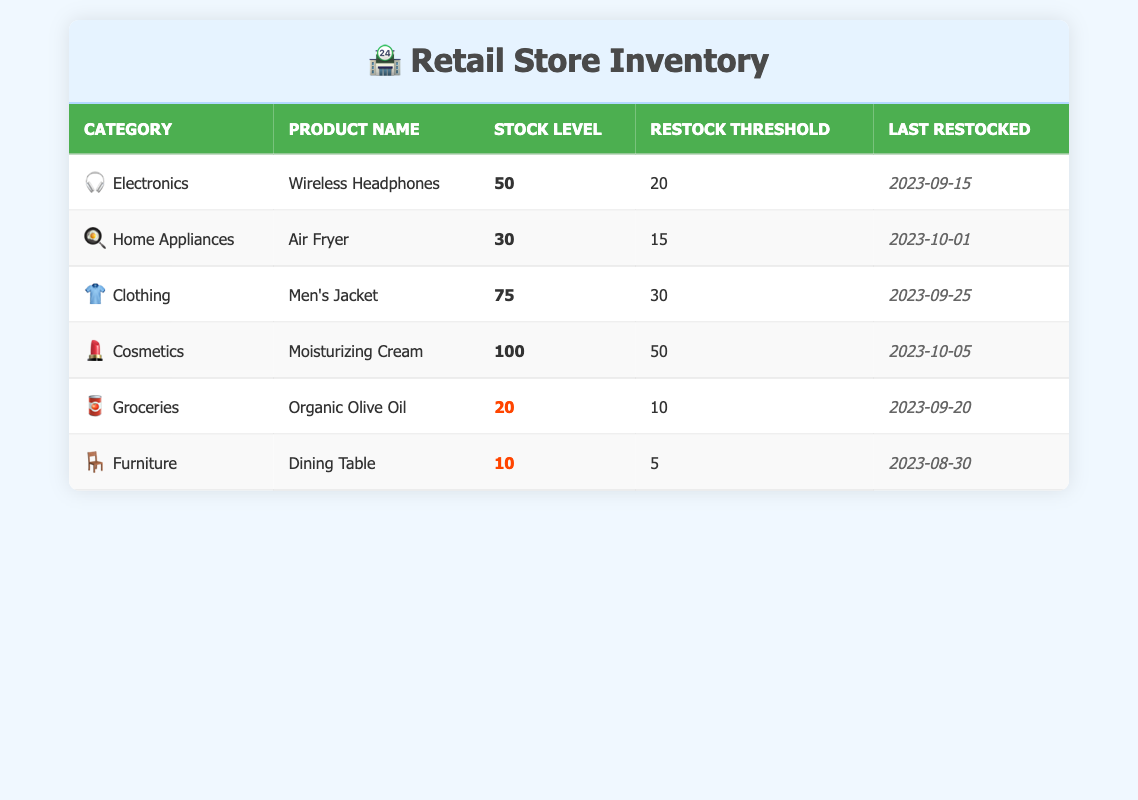What is the stock level of Wireless Headphones? The stock level for Wireless Headphones is directly listed in the table under the "Stock Level" column for the Electronics category.
Answer: 50 How many products have a stock level below their restock threshold? By examining the "Stock Level" and "Restock Threshold" columns, we find the products with stock levels below thresholds: Dining Table (10 < 5) and Organic Olive Oil (20 < 10). Therefore, there are two products below their thresholds.
Answer: 2 Is the stock level of the Air Fryer greater than the restock threshold? The stock level of the Air Fryer is 30, and its restock threshold is 15. Since 30 is greater than 15, the statement is true.
Answer: Yes What is the difference in stock level between Men's Jacket and Cosmetic products? The stock level for Men's Jacket is 75 and for Moisturizing Cream is 100. To find the difference, subtract: 100 - 75 = 25.
Answer: 25 Which product category has the highest stock level? By inspecting the stock levels for each product category, the stock level for Cosmetics (100) is the highest compared to Electronics (50), Home Appliances (30), Clothing (75), Groceries (20), and Furniture (10).
Answer: Cosmetics What is the average stock level of all products? The stock levels are 50, 30, 75, 100, 20, and 10. Adding them gives 50 + 30 + 75 + 100 + 20 + 10 = 285. Dividing by the number of products (6) yields 285 / 6 = 47.5.
Answer: 47.5 How many products have a last restock date in October 2023? The last restocked dates are: Air Fryer (October 1), Moisturizing Cream (October 5). Both are in October 2023, giving a total of two products.
Answer: 2 Does the stock level of the Dining Table meet its restock threshold? The Dining Table has a stock level of 10, and its restock threshold is 5. Since 10 is greater than 5, it meets the threshold.
Answer: Yes What is the stock level for all categories combined? The total stock levels are 50 (Electronics) + 30 (Home Appliances) + 75 (Clothing) + 100 (Cosmetics) + 20 (Groceries) + 10 (Furniture) = 285.
Answer: 285 